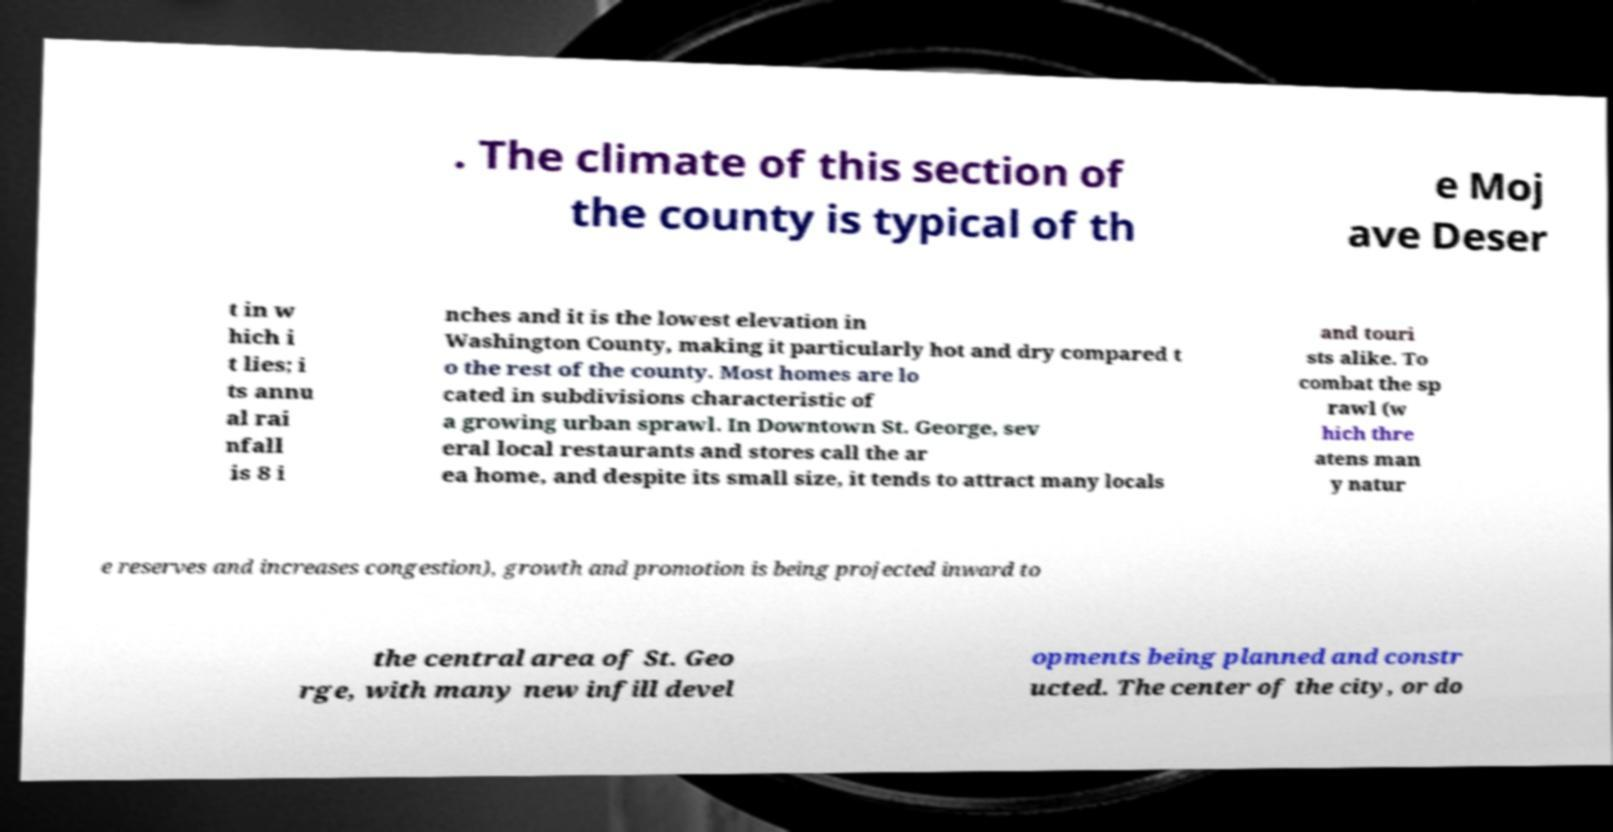What messages or text are displayed in this image? I need them in a readable, typed format. . The climate of this section of the county is typical of th e Moj ave Deser t in w hich i t lies; i ts annu al rai nfall is 8 i nches and it is the lowest elevation in Washington County, making it particularly hot and dry compared t o the rest of the county. Most homes are lo cated in subdivisions characteristic of a growing urban sprawl. In Downtown St. George, sev eral local restaurants and stores call the ar ea home, and despite its small size, it tends to attract many locals and touri sts alike. To combat the sp rawl (w hich thre atens man y natur e reserves and increases congestion), growth and promotion is being projected inward to the central area of St. Geo rge, with many new infill devel opments being planned and constr ucted. The center of the city, or do 